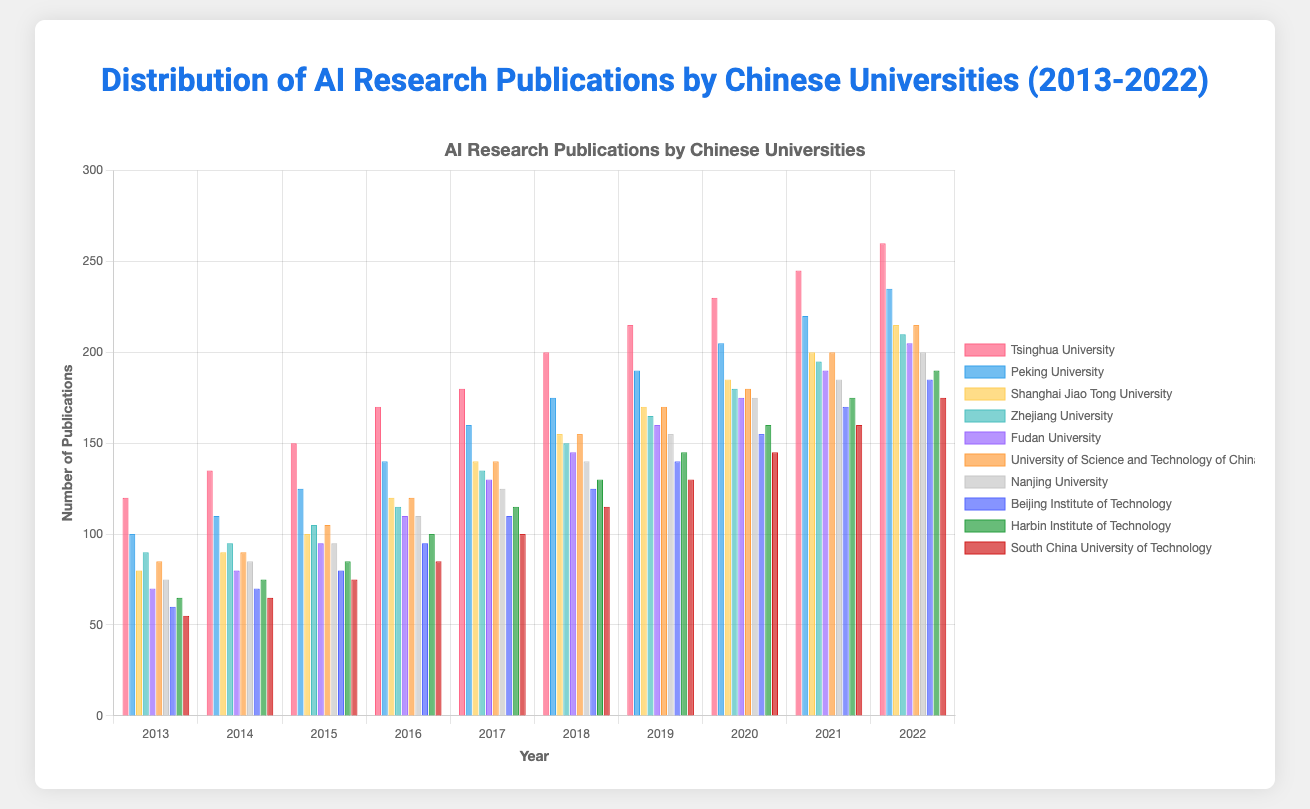What is the trend in AI research publications for Tsinghua University from 2013 to 2022? To assess the trend, observe the heights of the bars for Tsinghua University over the years from 2013 to 2022. The bars increase in height consistently, indicating a steady rise in publications each year.
Answer: Steady increase Which university had the highest number of AI research publications in 2022? Compare the height of the bars for each university in the year 2022. Tsinghua University has the tallest bar, indicating the highest number of publications.
Answer: Tsinghua University How many AI research publications did Peking University and Shanghai Jiao Tong University produce combined in 2017? Check the bars for Peking University and Shanghai Jiao Tong University in 2017. Peking University has 160 publications, and Shanghai Jiao Tong University has 140. Summing them gives 160 + 140.
Answer: 300 What is the average number of publications for Nanjing University from 2016 to 2020? Note the number of publications for Nanjing University from 2016 (110), 2017 (125), 2018 (140), 2019 (155), and 2020 (175). Sum these values (110 + 125 + 140 + 155 + 175) = 705. Divide by 5 to get the average, 705/5.
Answer: 141 Compare the number of AI research publications in 2015 between Tsinghua University and University of Science and Technology of China. Which had more, and by how many? Tsinghua University published 150, while University of Science and Technology of China published 105. The difference is 150 - 105.
Answer: Tsinghua by 45 Which university shows the most significant growth in AI research publications from 2013 to 2022? Assess the differences in the number of publications from 2013 to 2022 for each university and find the largest. Tsinghua University's growth is 260 - 120 = 140. No other university has a higher difference.
Answer: Tsinghua University In which year did Beijing Institute of Technology and Harbin Institute of Technology have an equal number of AI research publications? Check the bars for Beijing Institute of Technology and Harbin Institute of Technology year by year to find any year with equal heights. Both have 70 publications in 2014.
Answer: 2014 How do the 2022 AI research publications of South China University of Technology compare to those of Zhejiang University in 2018? Compare the heights of the bars: South China University of Technology had 175 publications in 2022, and Zhejiang University had 150 publications in 2018.
Answer: 25 more in 2022 If we consider only the year 2019, which university has the third highest number of AI research publications? Compare the bars for each university in 2019 and rank them. Tsinghua University is first, Peking University second, and University of Science and Technology of China third with 170 publications.
Answer: University of Science and Technology of China What is the difference in the number of AI research publications between Tsinghua University and Fudan University in 2022? Tsinghua University had 260 and Fudan University had 205 in 2022. Calculate the difference: 260 - 205.
Answer: 55 